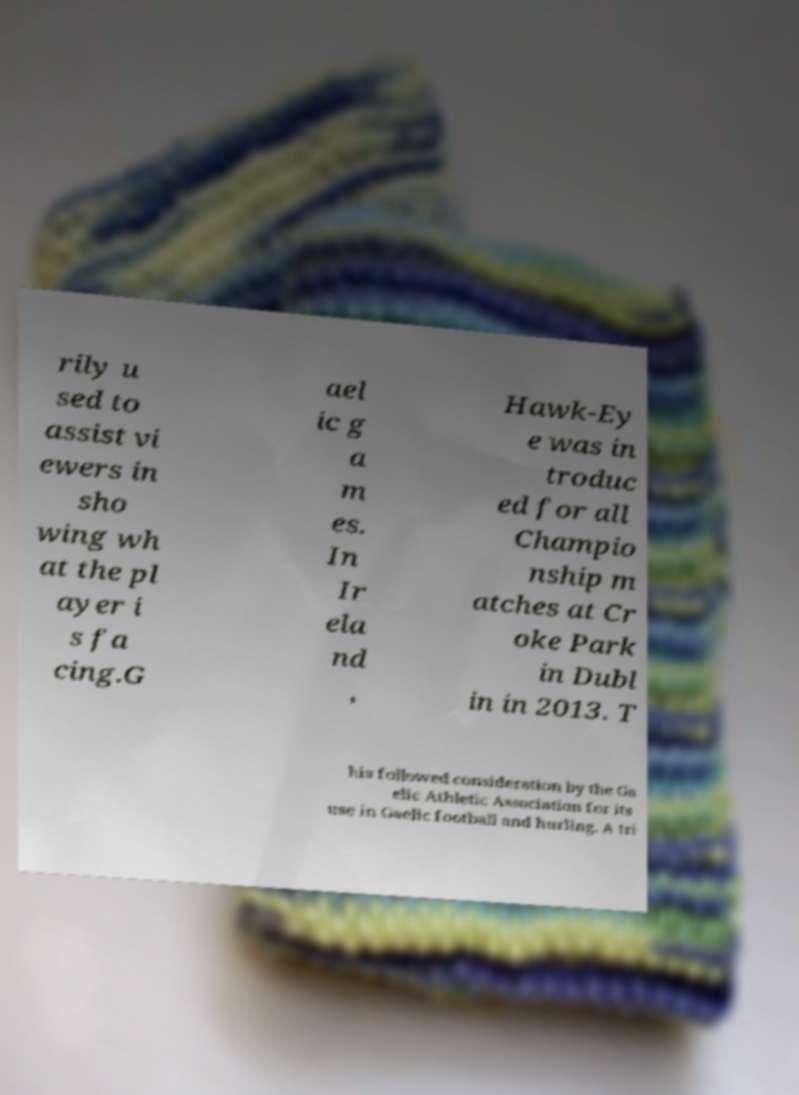What messages or text are displayed in this image? I need them in a readable, typed format. rily u sed to assist vi ewers in sho wing wh at the pl ayer i s fa cing.G ael ic g a m es. In Ir ela nd , Hawk-Ey e was in troduc ed for all Champio nship m atches at Cr oke Park in Dubl in in 2013. T his followed consideration by the Ga elic Athletic Association for its use in Gaelic football and hurling. A tri 